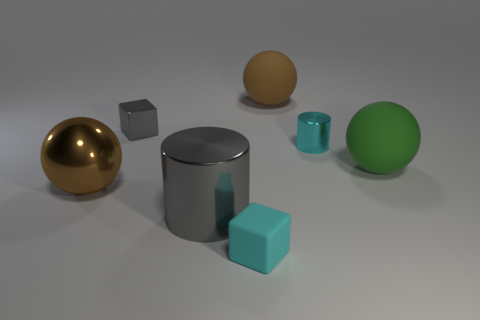Add 1 cyan objects. How many objects exist? 8 Subtract all large green spheres. How many spheres are left? 2 Subtract 3 spheres. How many spheres are left? 0 Subtract all purple cylinders. How many green balls are left? 1 Subtract all brown metal spheres. Subtract all tiny gray metallic blocks. How many objects are left? 5 Add 2 matte things. How many matte things are left? 5 Add 4 large green matte things. How many large green matte things exist? 5 Subtract all green spheres. How many spheres are left? 2 Subtract 0 yellow spheres. How many objects are left? 7 Subtract all blocks. How many objects are left? 5 